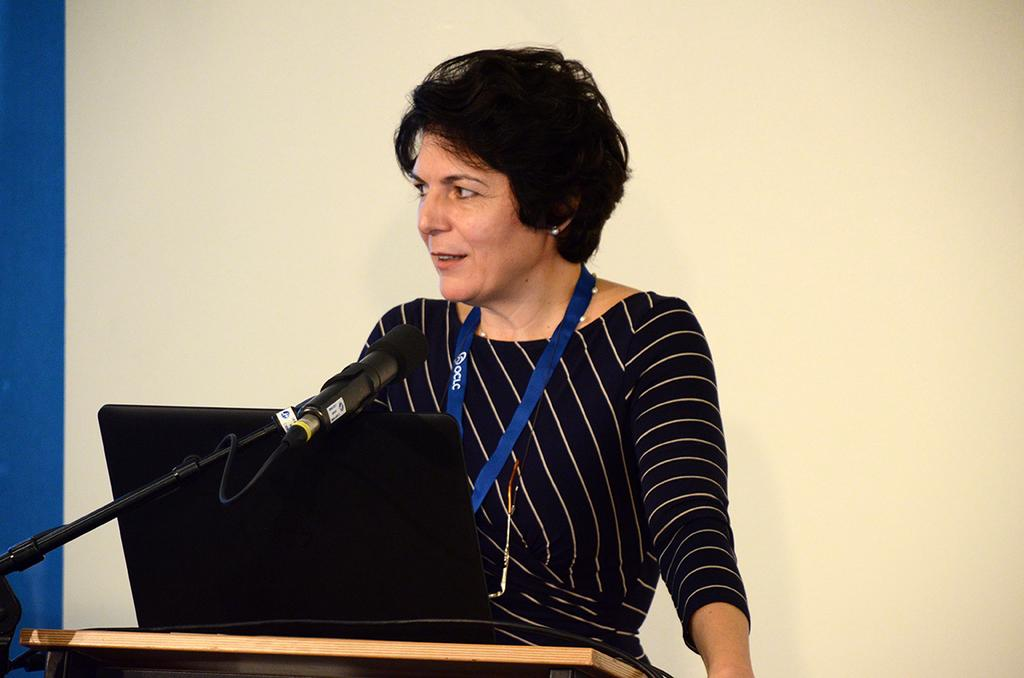Who is the main subject in the image? There is a lady in the image. What is the lady doing in the image? The lady is standing in front of a desk. What objects can be seen on the desk? There is a microphone (mic) and a laptop on the desk. What advice does the lady give to the person who dropped the respect in the image? There is no person who dropped the respect in the image, and the lady is not giving any advice. 